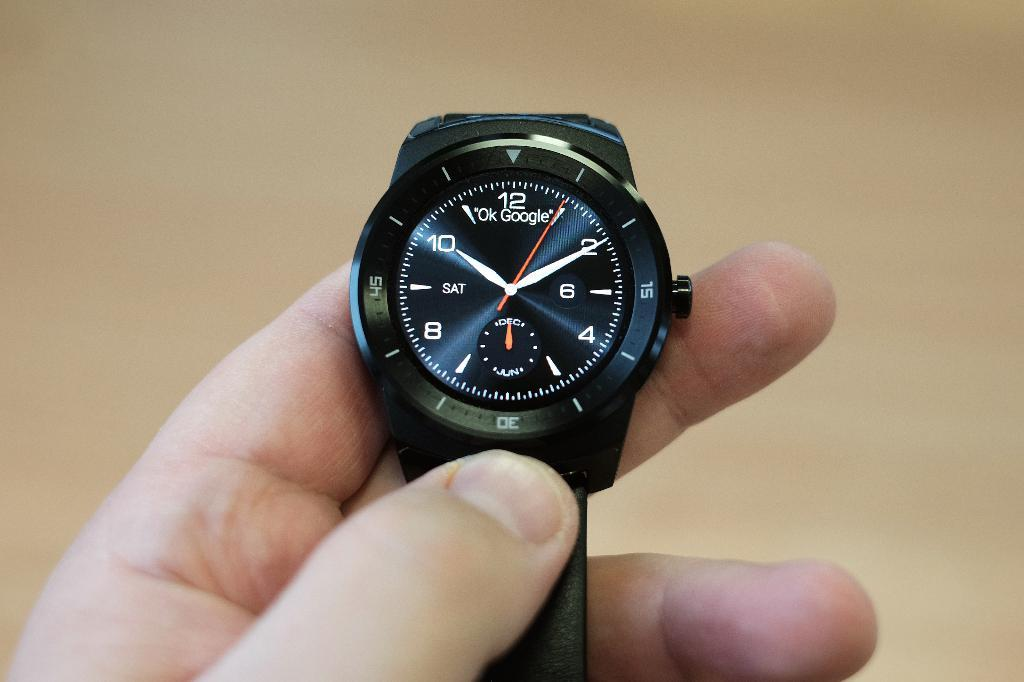<image>
Describe the image concisely. A man is holding up a black OK google watch. 